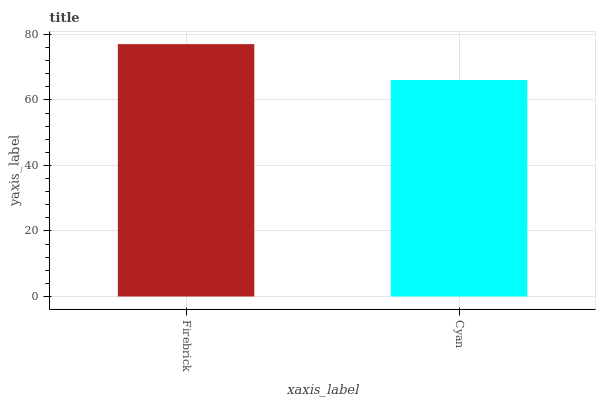Is Cyan the minimum?
Answer yes or no. Yes. Is Firebrick the maximum?
Answer yes or no. Yes. Is Cyan the maximum?
Answer yes or no. No. Is Firebrick greater than Cyan?
Answer yes or no. Yes. Is Cyan less than Firebrick?
Answer yes or no. Yes. Is Cyan greater than Firebrick?
Answer yes or no. No. Is Firebrick less than Cyan?
Answer yes or no. No. Is Firebrick the high median?
Answer yes or no. Yes. Is Cyan the low median?
Answer yes or no. Yes. Is Cyan the high median?
Answer yes or no. No. Is Firebrick the low median?
Answer yes or no. No. 